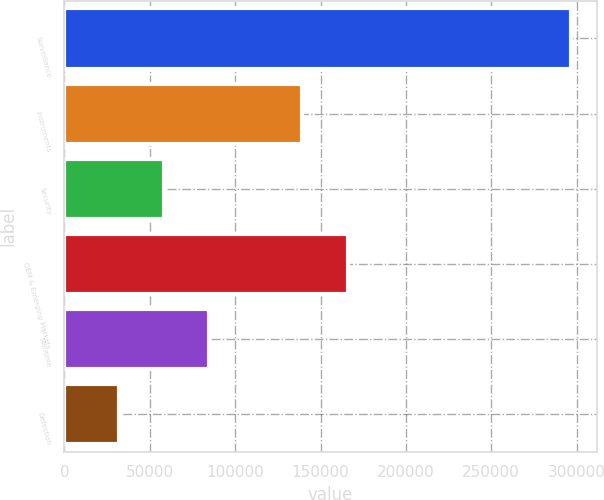Convert chart. <chart><loc_0><loc_0><loc_500><loc_500><bar_chart><fcel>Surveillance<fcel>Instruments<fcel>Security<fcel>OEM & Emerging Markets<fcel>Maritime<fcel>Detection<nl><fcel>296891<fcel>139367<fcel>58346.9<fcel>165872<fcel>84851.8<fcel>31842<nl></chart> 